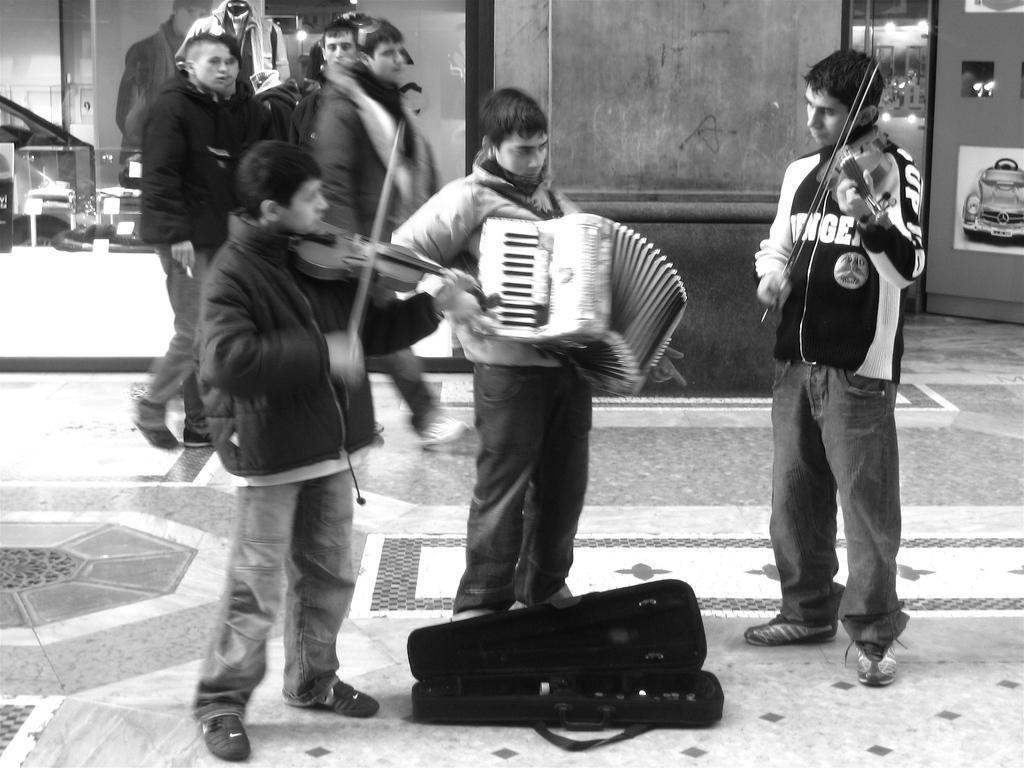Could you give a brief overview of what you see in this image? Here men are playing musical instruments, here other people are walking, this is car. 